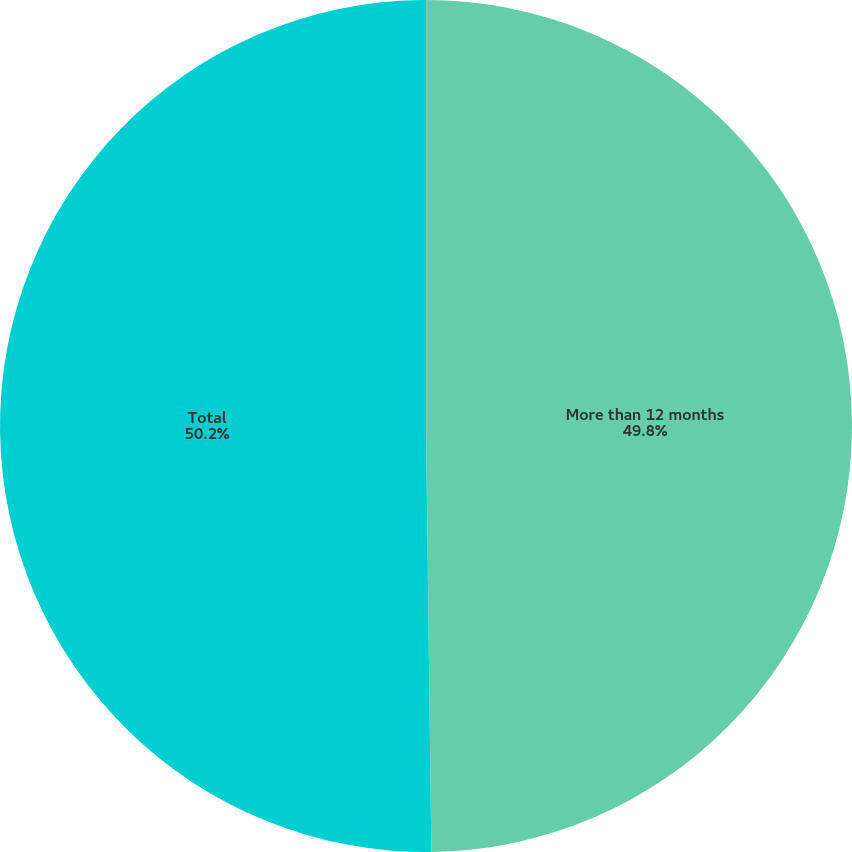Convert chart. <chart><loc_0><loc_0><loc_500><loc_500><pie_chart><fcel>More than 12 months<fcel>Total<nl><fcel>49.8%<fcel>50.2%<nl></chart> 